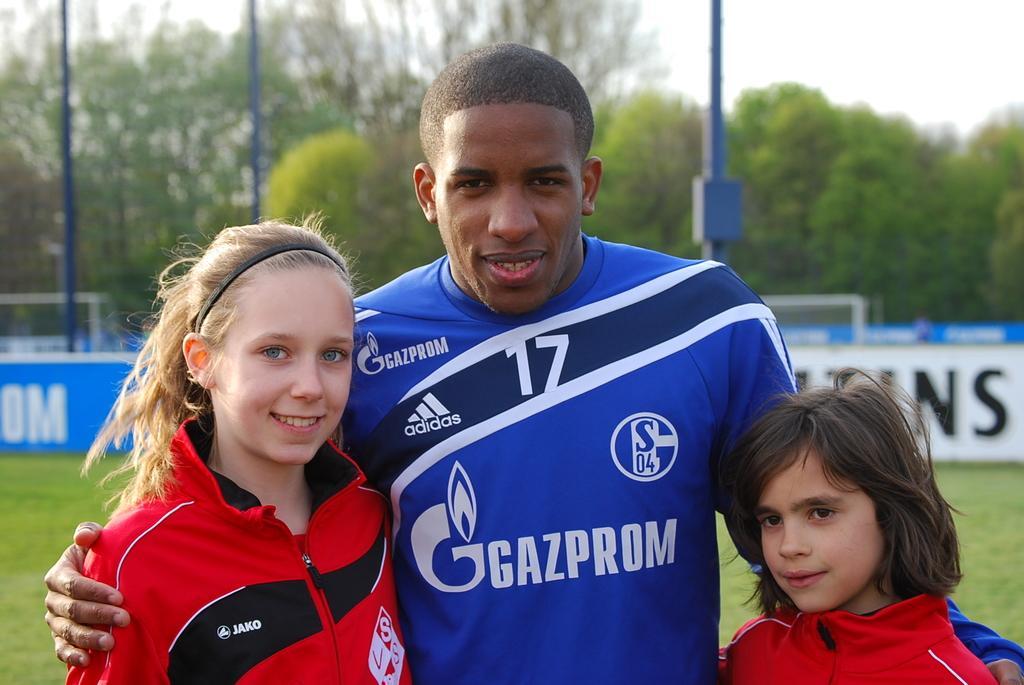How would you summarize this image in a sentence or two? There is a person in blue color t-shirt smiling, standing and holding two children who are in red color t-shirts and are smiling and standing. In the background, there is grass on the ground, there are hoardings, trees, poles and sky. 